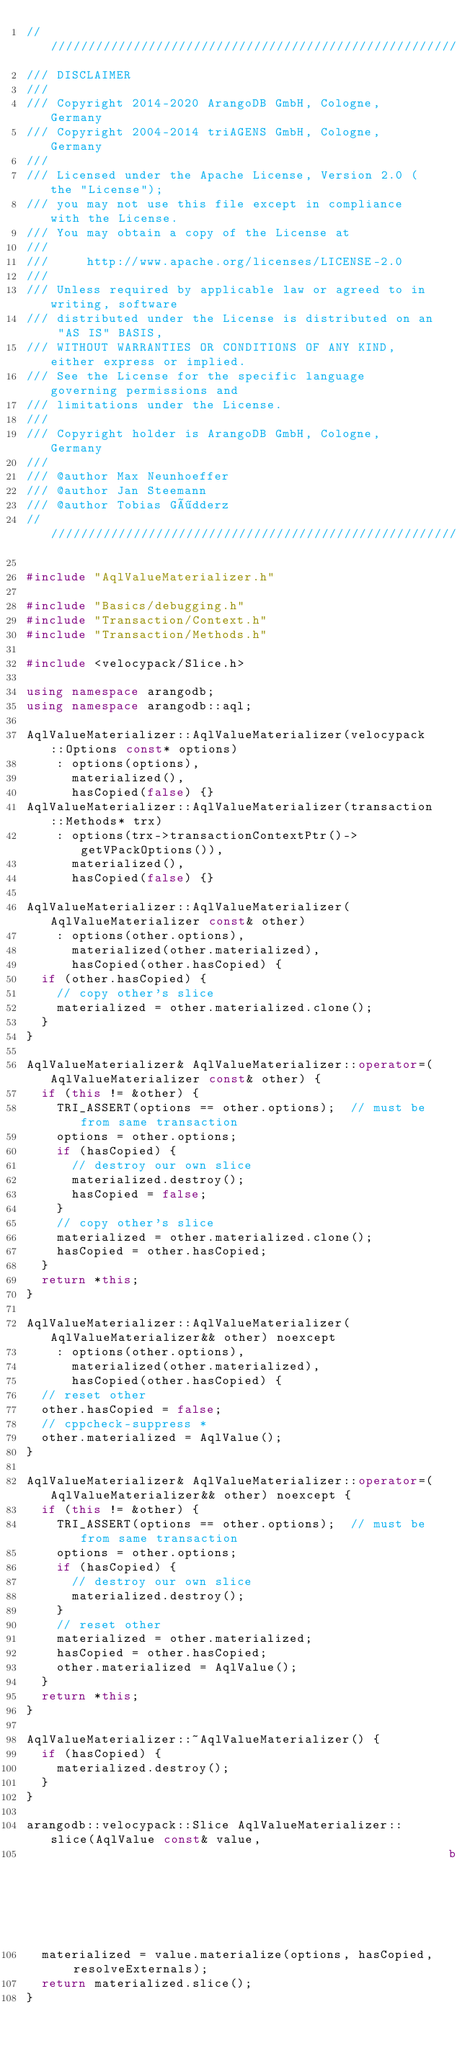Convert code to text. <code><loc_0><loc_0><loc_500><loc_500><_C++_>////////////////////////////////////////////////////////////////////////////////
/// DISCLAIMER
///
/// Copyright 2014-2020 ArangoDB GmbH, Cologne, Germany
/// Copyright 2004-2014 triAGENS GmbH, Cologne, Germany
///
/// Licensed under the Apache License, Version 2.0 (the "License");
/// you may not use this file except in compliance with the License.
/// You may obtain a copy of the License at
///
///     http://www.apache.org/licenses/LICENSE-2.0
///
/// Unless required by applicable law or agreed to in writing, software
/// distributed under the License is distributed on an "AS IS" BASIS,
/// WITHOUT WARRANTIES OR CONDITIONS OF ANY KIND, either express or implied.
/// See the License for the specific language governing permissions and
/// limitations under the License.
///
/// Copyright holder is ArangoDB GmbH, Cologne, Germany
///
/// @author Max Neunhoeffer
/// @author Jan Steemann
/// @author Tobias Gödderz
////////////////////////////////////////////////////////////////////////////////

#include "AqlValueMaterializer.h"

#include "Basics/debugging.h"
#include "Transaction/Context.h"
#include "Transaction/Methods.h"

#include <velocypack/Slice.h>

using namespace arangodb;
using namespace arangodb::aql;

AqlValueMaterializer::AqlValueMaterializer(velocypack::Options const* options)
    : options(options),
      materialized(),
      hasCopied(false) {}
AqlValueMaterializer::AqlValueMaterializer(transaction::Methods* trx)
    : options(trx->transactionContextPtr()->getVPackOptions()),
      materialized(),
      hasCopied(false) {}

AqlValueMaterializer::AqlValueMaterializer(AqlValueMaterializer const& other)
    : options(other.options),
      materialized(other.materialized),
      hasCopied(other.hasCopied) {
  if (other.hasCopied) {
    // copy other's slice
    materialized = other.materialized.clone();
  }
}

AqlValueMaterializer& AqlValueMaterializer::operator=(AqlValueMaterializer const& other) {
  if (this != &other) {
    TRI_ASSERT(options == other.options);  // must be from same transaction
    options = other.options;
    if (hasCopied) {
      // destroy our own slice
      materialized.destroy();
      hasCopied = false;
    }
    // copy other's slice
    materialized = other.materialized.clone();
    hasCopied = other.hasCopied;
  }
  return *this;
}

AqlValueMaterializer::AqlValueMaterializer(AqlValueMaterializer&& other) noexcept
    : options(other.options),
      materialized(other.materialized),
      hasCopied(other.hasCopied) {
  // reset other
  other.hasCopied = false;
  // cppcheck-suppress *
  other.materialized = AqlValue();
}

AqlValueMaterializer& AqlValueMaterializer::operator=(AqlValueMaterializer&& other) noexcept {
  if (this != &other) {
    TRI_ASSERT(options == other.options);  // must be from same transaction
    options = other.options;
    if (hasCopied) {
      // destroy our own slice
      materialized.destroy();
    }
    // reset other
    materialized = other.materialized;
    hasCopied = other.hasCopied;
    other.materialized = AqlValue();
  }
  return *this;
}

AqlValueMaterializer::~AqlValueMaterializer() {
  if (hasCopied) {
    materialized.destroy();
  }
}

arangodb::velocypack::Slice AqlValueMaterializer::slice(AqlValue const& value,
                                                        bool resolveExternals) {
  materialized = value.materialize(options, hasCopied, resolveExternals);
  return materialized.slice();
}
</code> 